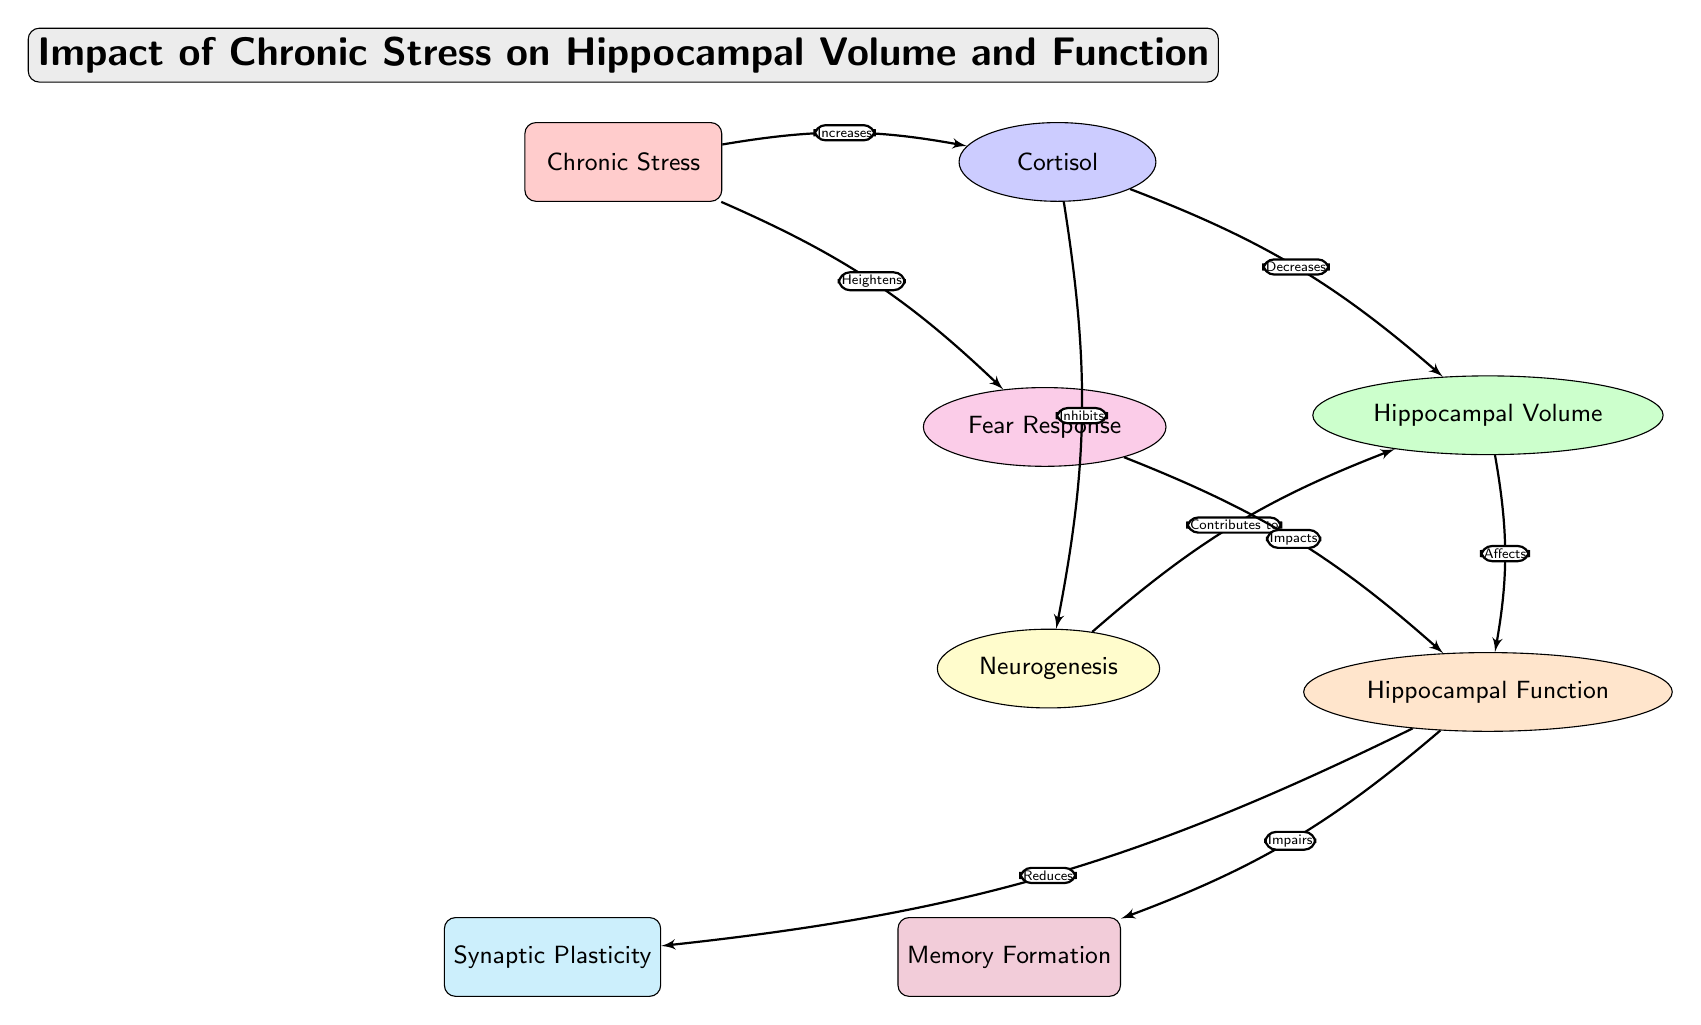What is the main node of the diagram? The main node is labeled "Chronic Stress," which serves as the starting point for the flow of effects in the diagram.
Answer: Chronic Stress How many effect nodes are there in total? There are five effect nodes in the diagram: Cortisol, Hippocampal Volume, Neurogenesis, Hippocampal Function, and Fear Response.
Answer: Five Which effect is directly affected by increased cortisol? Increased cortisol decreases Hippocampal Volume directly according to the flow depicted in the diagram.
Answer: Hippocampal Volume What effect does neurogenesis contribute to? Neurogenesis contributes to the Hippocampal Volume as indicated by the directional flow from Neurogenesis to Hippocampal Volume.
Answer: Hippocampal Volume What is the relationship between hippocampal function and memory formation? Hippocampal Function impairs Memory Formation as directed in the diagram.
Answer: Impairs What node affects the relationship between chronic stress and hippocampal function? The node that affects this relationship is Fear Response, which is increased by Chronic Stress and impacts Hippocampal Function.
Answer: Fear Response What process is inhibited by cortisol according to the diagram? The process that is inhibited by cortisol is Neurogenesis, indicating a negative effect on this aspect of hippocampal function.
Answer: Neurogenesis How does chronic stress impact fear response? Chronic Stress heightens Fear Response, illustrating an increase in this psychological response due to the stress.
Answer: Heightens What is reduced by hippocampal function? Synaptic Plasticity is reduced by Hippocampal Function according to the directional flow in the diagram.
Answer: Reduced 